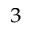Convert formula to latex. <formula><loc_0><loc_0><loc_500><loc_500>^ { 3 }</formula> 